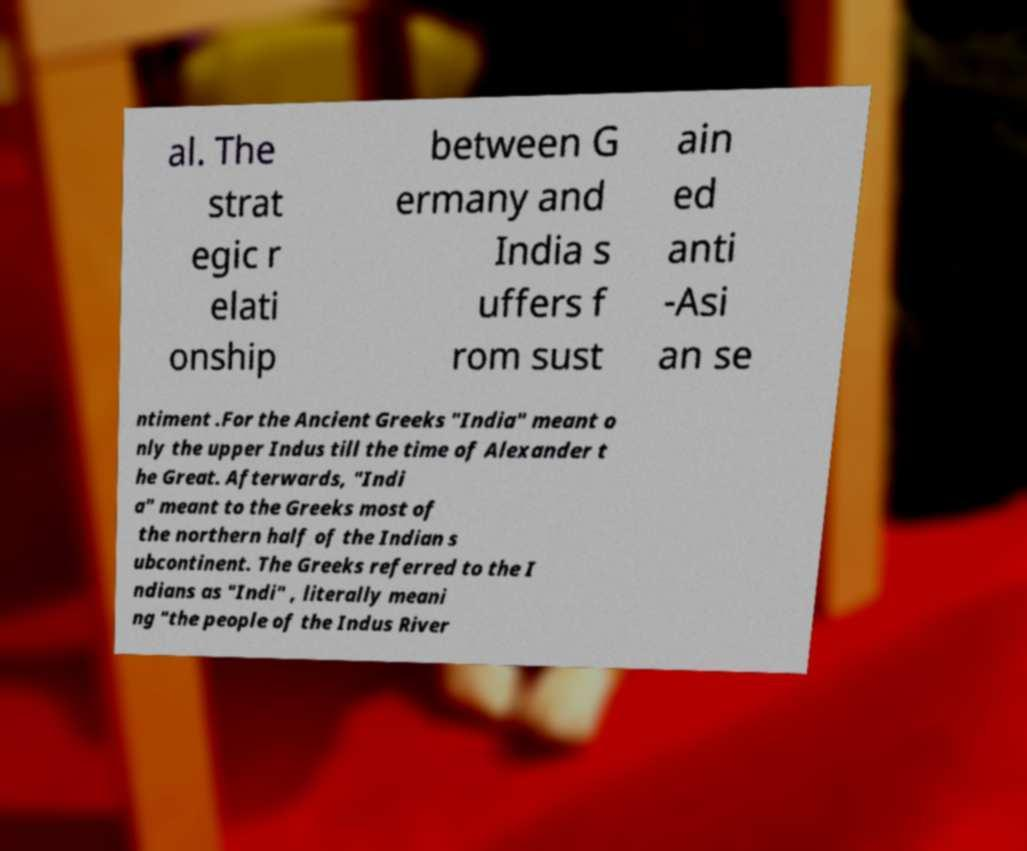Can you read and provide the text displayed in the image?This photo seems to have some interesting text. Can you extract and type it out for me? al. The strat egic r elati onship between G ermany and India s uffers f rom sust ain ed anti -Asi an se ntiment .For the Ancient Greeks "India" meant o nly the upper Indus till the time of Alexander t he Great. Afterwards, "Indi a" meant to the Greeks most of the northern half of the Indian s ubcontinent. The Greeks referred to the I ndians as "Indi" , literally meani ng "the people of the Indus River 